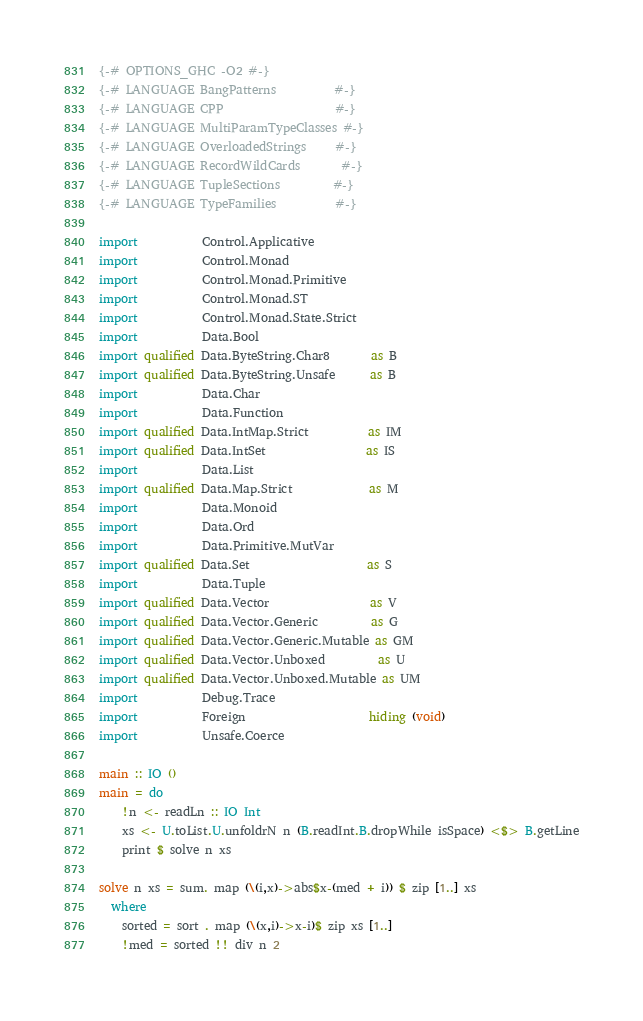<code> <loc_0><loc_0><loc_500><loc_500><_Haskell_>{-# OPTIONS_GHC -O2 #-}
{-# LANGUAGE BangPatterns          #-}
{-# LANGUAGE CPP                   #-}
{-# LANGUAGE MultiParamTypeClasses #-}
{-# LANGUAGE OverloadedStrings     #-}
{-# LANGUAGE RecordWildCards       #-}
{-# LANGUAGE TupleSections         #-}
{-# LANGUAGE TypeFamilies          #-}

import           Control.Applicative
import           Control.Monad
import           Control.Monad.Primitive
import           Control.Monad.ST
import           Control.Monad.State.Strict
import           Data.Bool
import qualified Data.ByteString.Char8       as B
import qualified Data.ByteString.Unsafe      as B
import           Data.Char
import           Data.Function
import qualified Data.IntMap.Strict          as IM
import qualified Data.IntSet                 as IS
import           Data.List
import qualified Data.Map.Strict             as M
import           Data.Monoid
import           Data.Ord
import           Data.Primitive.MutVar
import qualified Data.Set                    as S
import           Data.Tuple
import qualified Data.Vector                 as V
import qualified Data.Vector.Generic         as G
import qualified Data.Vector.Generic.Mutable as GM
import qualified Data.Vector.Unboxed         as U
import qualified Data.Vector.Unboxed.Mutable as UM
import           Debug.Trace
import           Foreign                     hiding (void)
import           Unsafe.Coerce

main :: IO ()
main = do
    !n <- readLn :: IO Int
    xs <- U.toList.U.unfoldrN n (B.readInt.B.dropWhile isSpace) <$> B.getLine
    print $ solve n xs

solve n xs = sum. map (\(i,x)->abs$x-(med + i)) $ zip [1..] xs
  where
    sorted = sort . map (\(x,i)->x-i)$ zip xs [1..]
    !med = sorted !! div n 2
</code> 